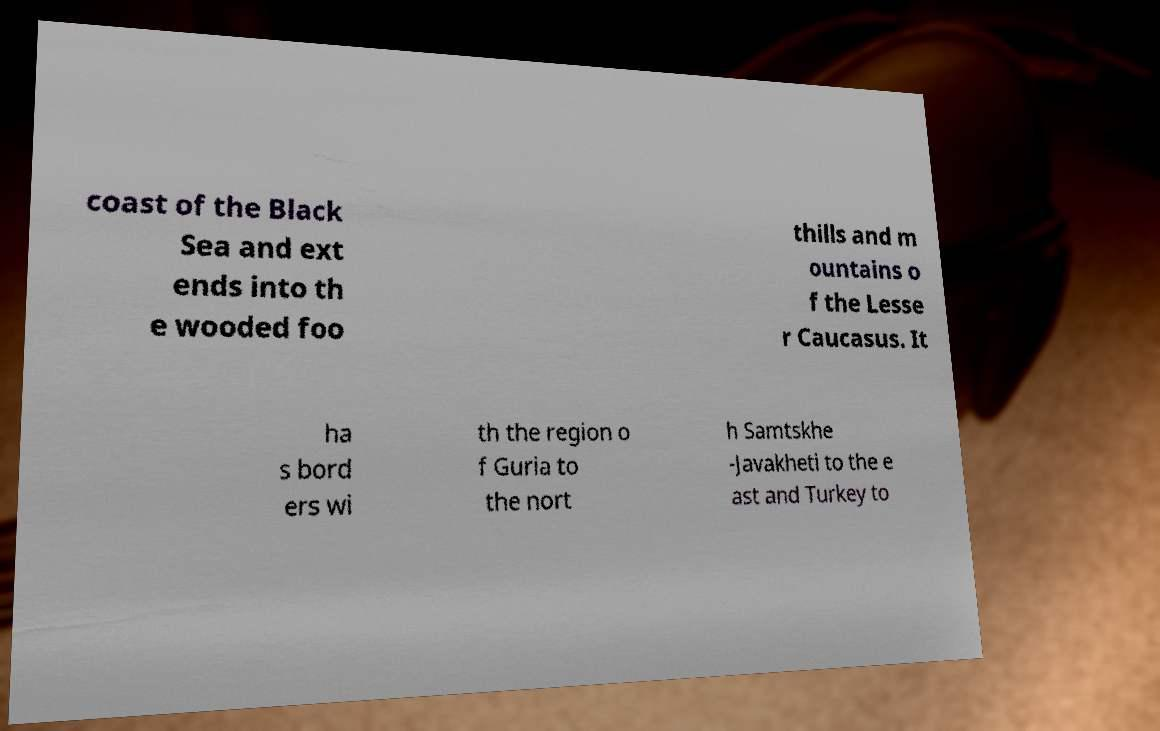For documentation purposes, I need the text within this image transcribed. Could you provide that? coast of the Black Sea and ext ends into th e wooded foo thills and m ountains o f the Lesse r Caucasus. It ha s bord ers wi th the region o f Guria to the nort h Samtskhe -Javakheti to the e ast and Turkey to 